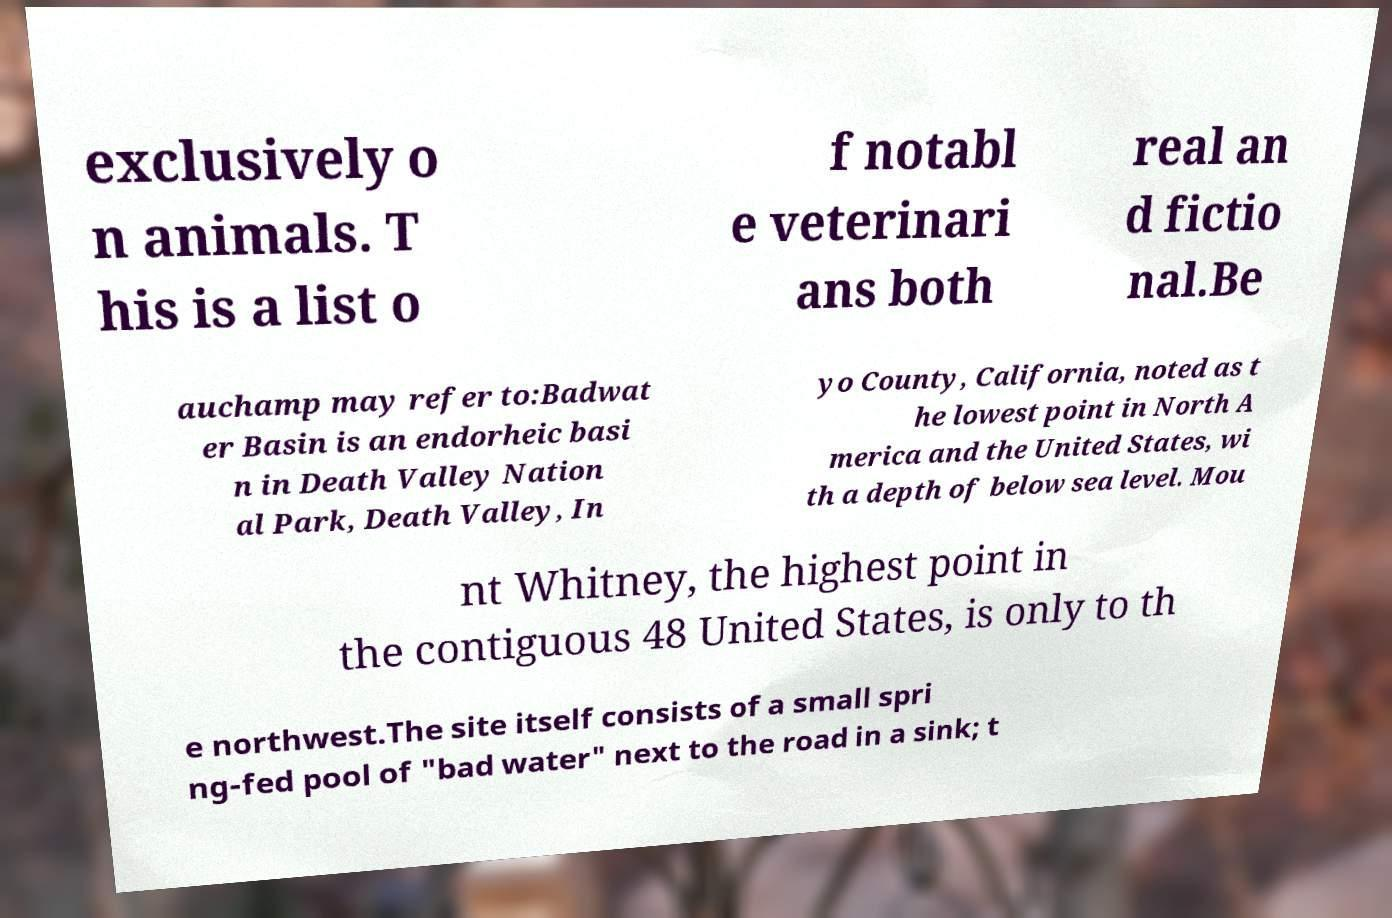Can you accurately transcribe the text from the provided image for me? exclusively o n animals. T his is a list o f notabl e veterinari ans both real an d fictio nal.Be auchamp may refer to:Badwat er Basin is an endorheic basi n in Death Valley Nation al Park, Death Valley, In yo County, California, noted as t he lowest point in North A merica and the United States, wi th a depth of below sea level. Mou nt Whitney, the highest point in the contiguous 48 United States, is only to th e northwest.The site itself consists of a small spri ng-fed pool of "bad water" next to the road in a sink; t 